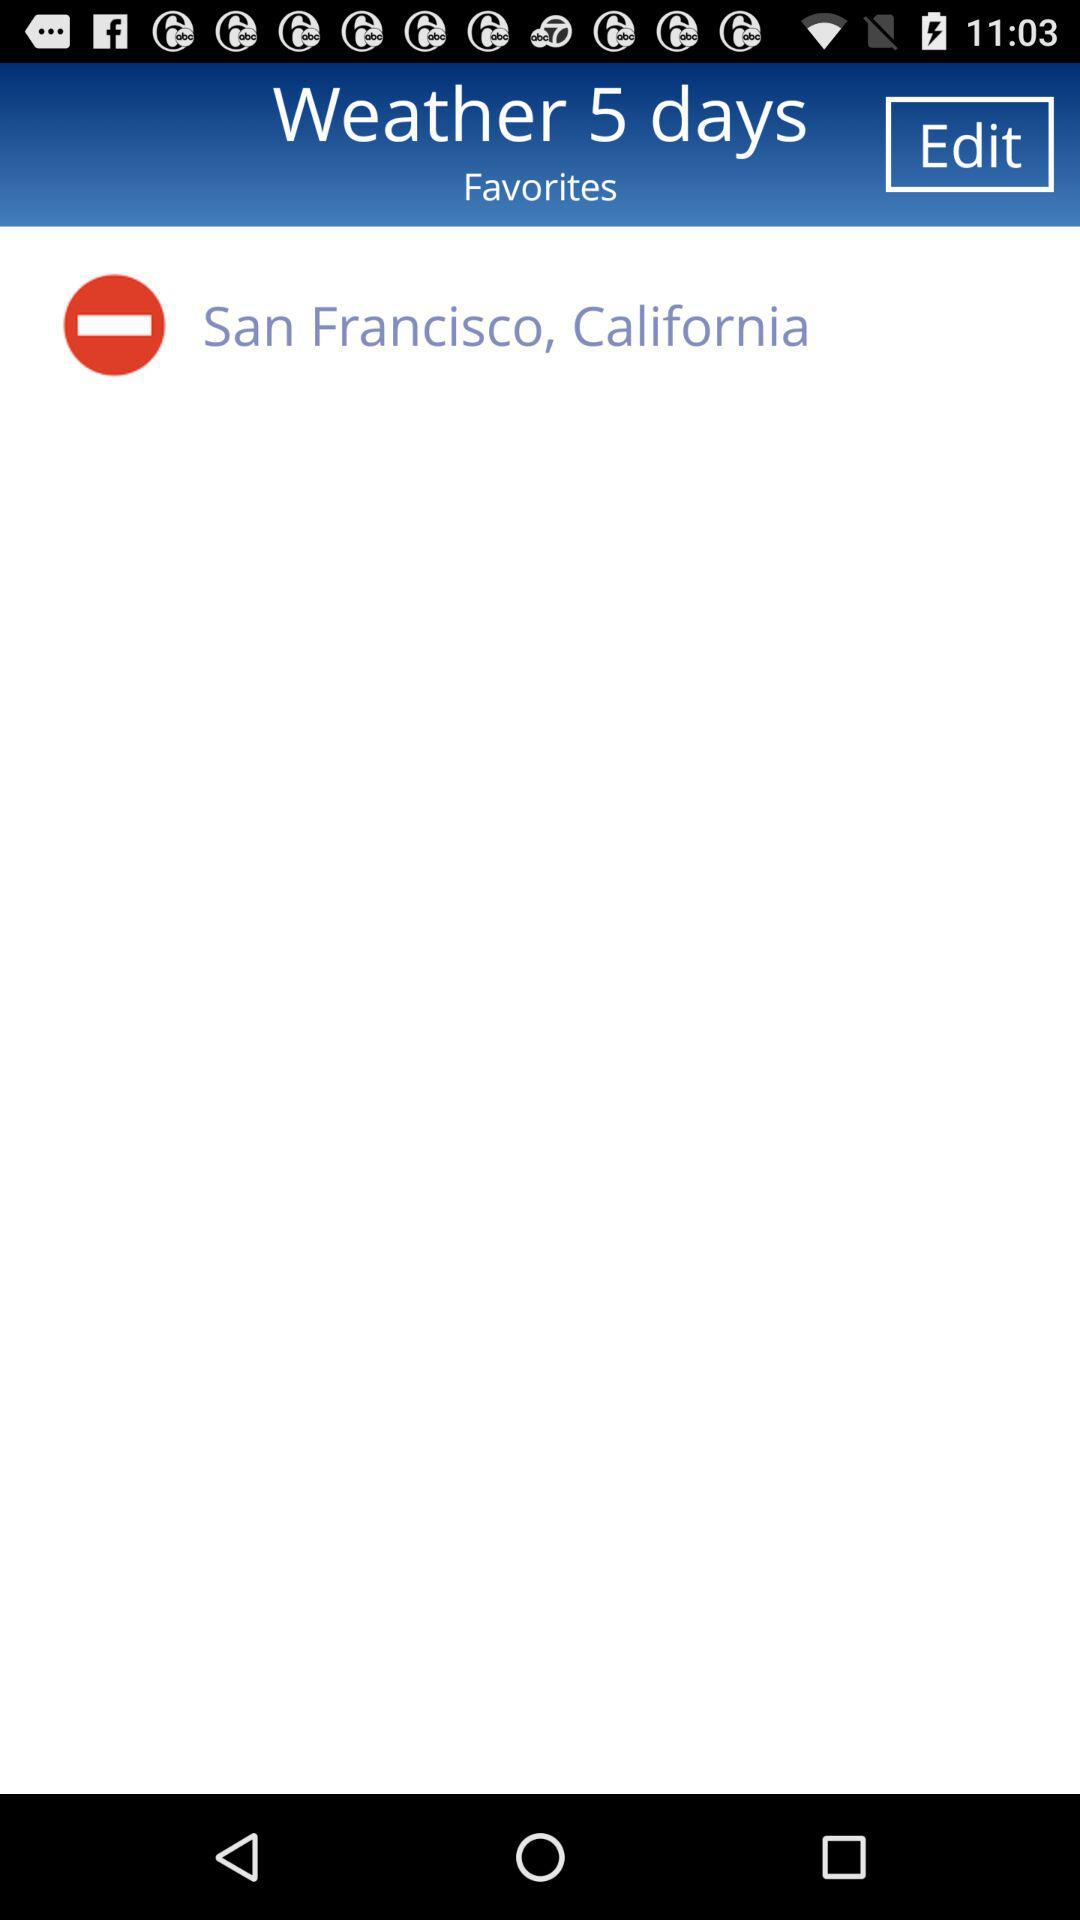What city name is there? The city name is San Francisco. 